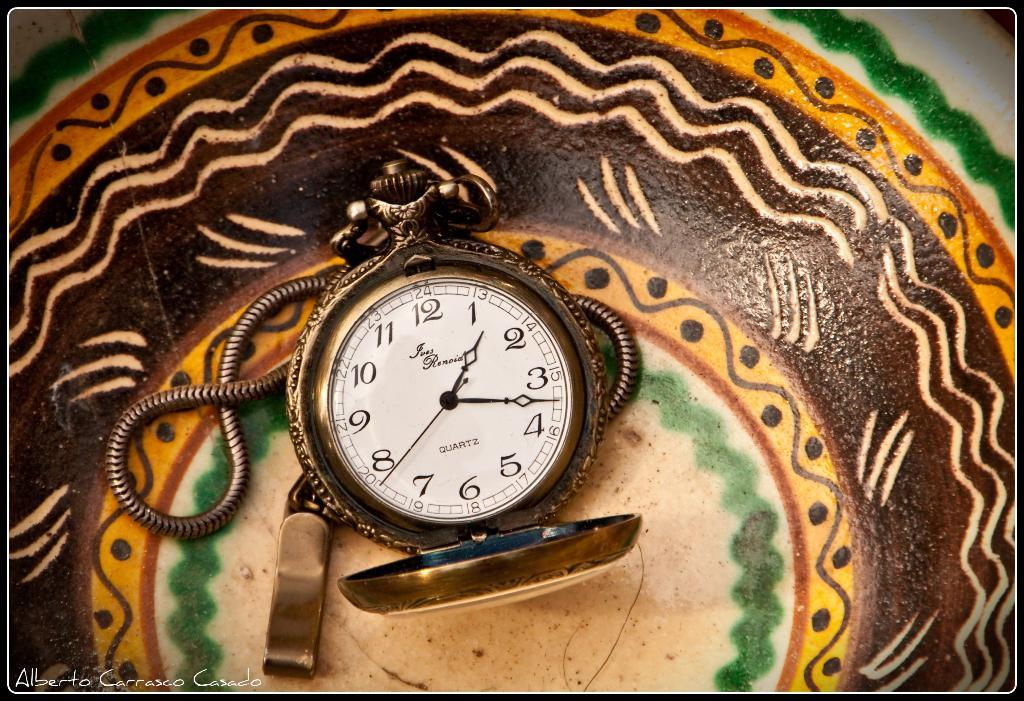Provide a one-sentence caption for the provided image. A picture of a clock that reads 1:17 was painted by a man named Alberto. 